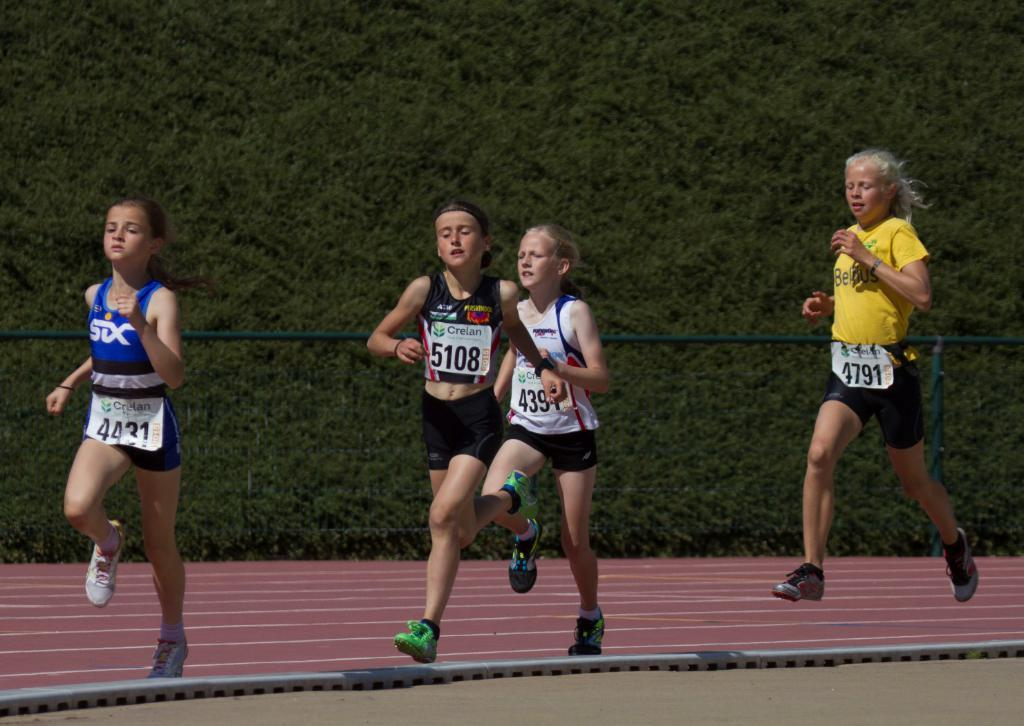What are the people in the image doing? The people in the image are running. What objects can be seen in the image besides the people? There is a pole and a metal rod in the image. What can be seen in the background of the image? There are trees in the background of the image. What type of skirt is the plantation wearing in the image? There is no plantation or skirt present in the image. 